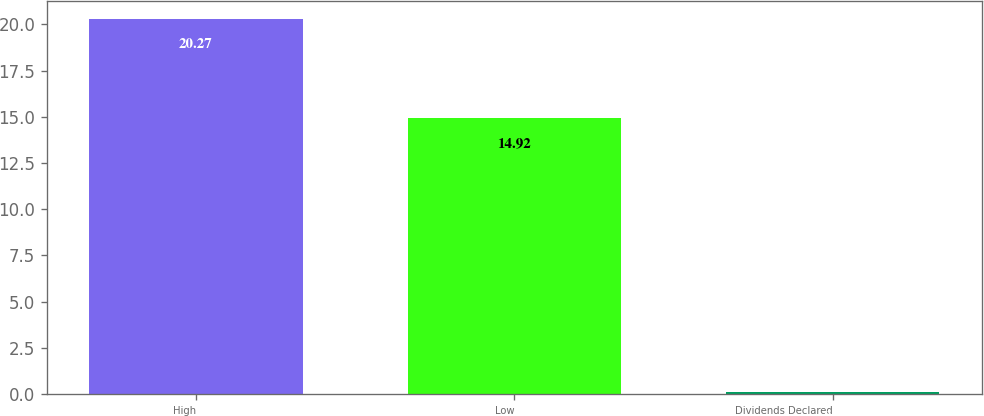Convert chart. <chart><loc_0><loc_0><loc_500><loc_500><bar_chart><fcel>High<fcel>Low<fcel>Dividends Declared<nl><fcel>20.27<fcel>14.92<fcel>0.1<nl></chart> 